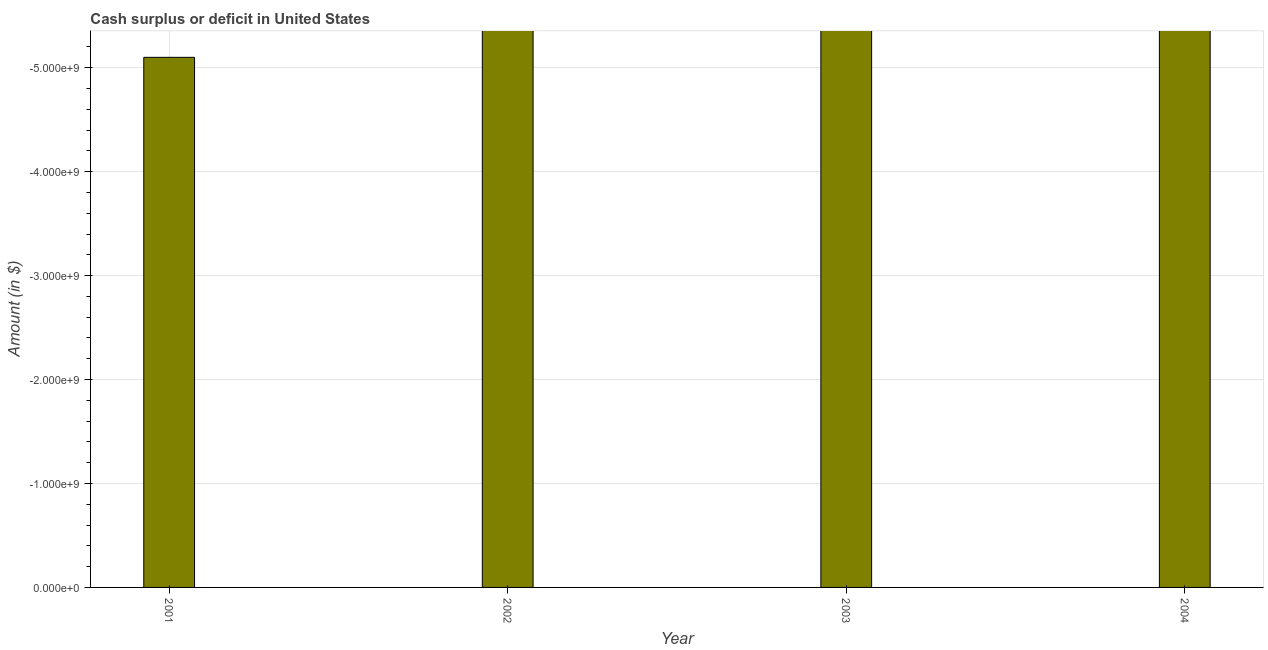Does the graph contain any zero values?
Give a very brief answer. Yes. What is the title of the graph?
Make the answer very short. Cash surplus or deficit in United States. What is the label or title of the X-axis?
Give a very brief answer. Year. What is the label or title of the Y-axis?
Offer a very short reply. Amount (in $). What is the median cash surplus or deficit?
Make the answer very short. 0. In how many years, is the cash surplus or deficit greater than the average cash surplus or deficit taken over all years?
Keep it short and to the point. 0. Are all the bars in the graph horizontal?
Your answer should be very brief. No. How many years are there in the graph?
Your response must be concise. 4. What is the difference between two consecutive major ticks on the Y-axis?
Ensure brevity in your answer.  1.00e+09. Are the values on the major ticks of Y-axis written in scientific E-notation?
Keep it short and to the point. Yes. 